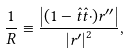<formula> <loc_0><loc_0><loc_500><loc_500>\frac { 1 } { R } \equiv \frac { \left | ( 1 - \hat { t } \hat { t } \cdot ) r ^ { \prime \prime } \right | } { \left | r ^ { \prime } \right | ^ { 2 } } ,</formula> 